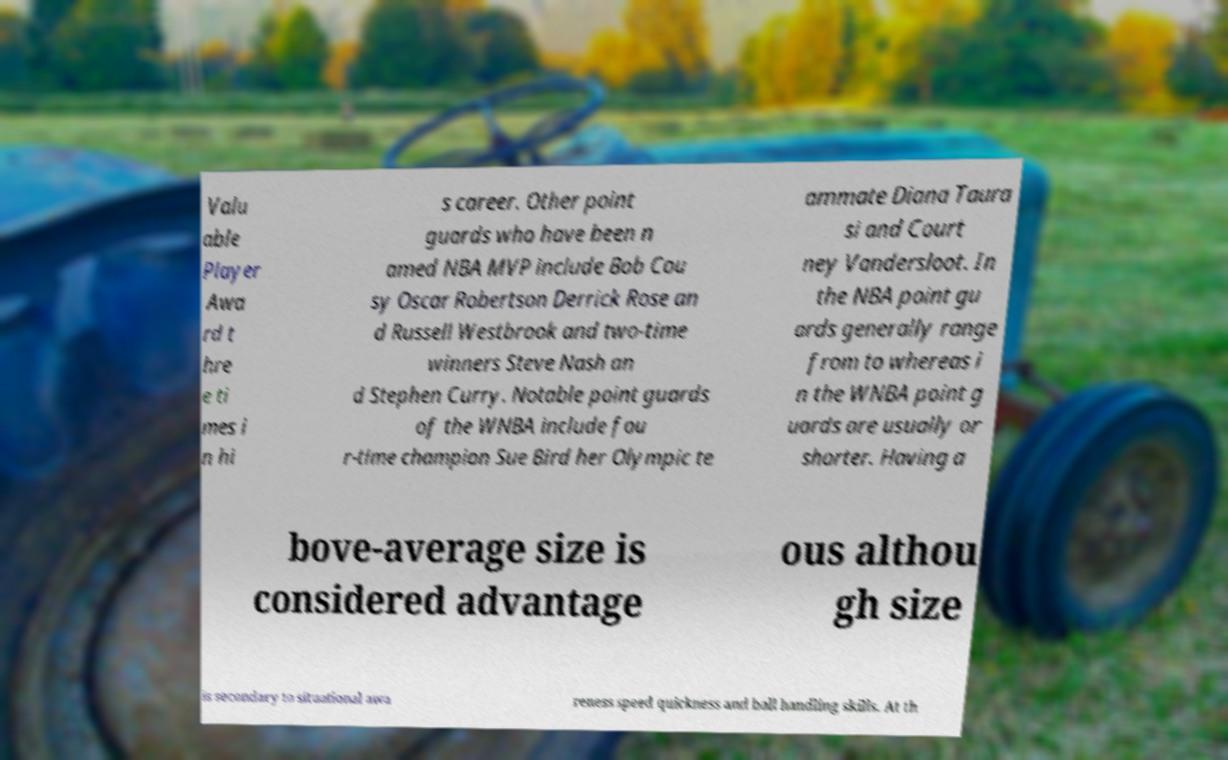What messages or text are displayed in this image? I need them in a readable, typed format. Valu able Player Awa rd t hre e ti mes i n hi s career. Other point guards who have been n amed NBA MVP include Bob Cou sy Oscar Robertson Derrick Rose an d Russell Westbrook and two-time winners Steve Nash an d Stephen Curry. Notable point guards of the WNBA include fou r-time champion Sue Bird her Olympic te ammate Diana Taura si and Court ney Vandersloot. In the NBA point gu ards generally range from to whereas i n the WNBA point g uards are usually or shorter. Having a bove-average size is considered advantage ous althou gh size is secondary to situational awa reness speed quickness and ball handling skills. At th 